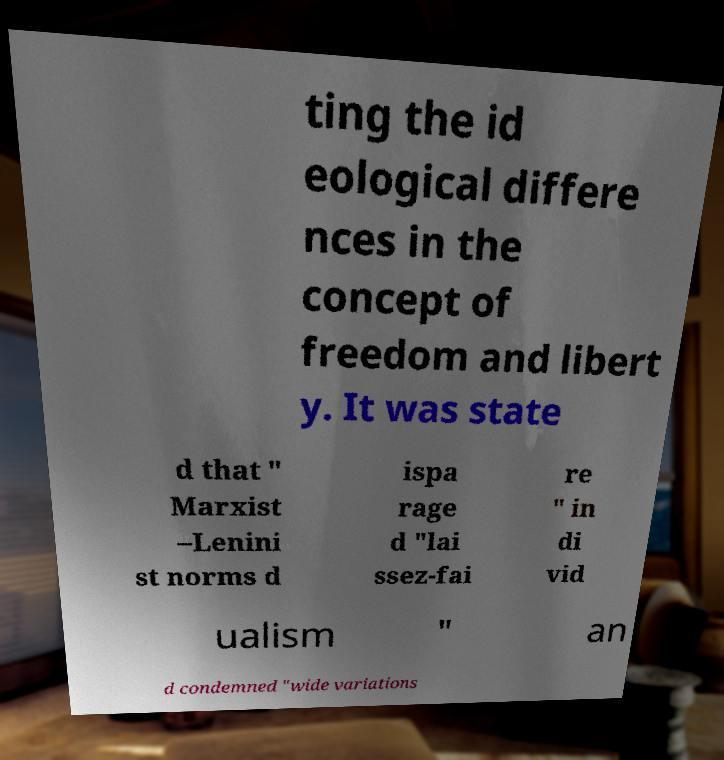Please identify and transcribe the text found in this image. ting the id eological differe nces in the concept of freedom and libert y. It was state d that " Marxist –Lenini st norms d ispa rage d "lai ssez-fai re " in di vid ualism " an d condemned "wide variations 